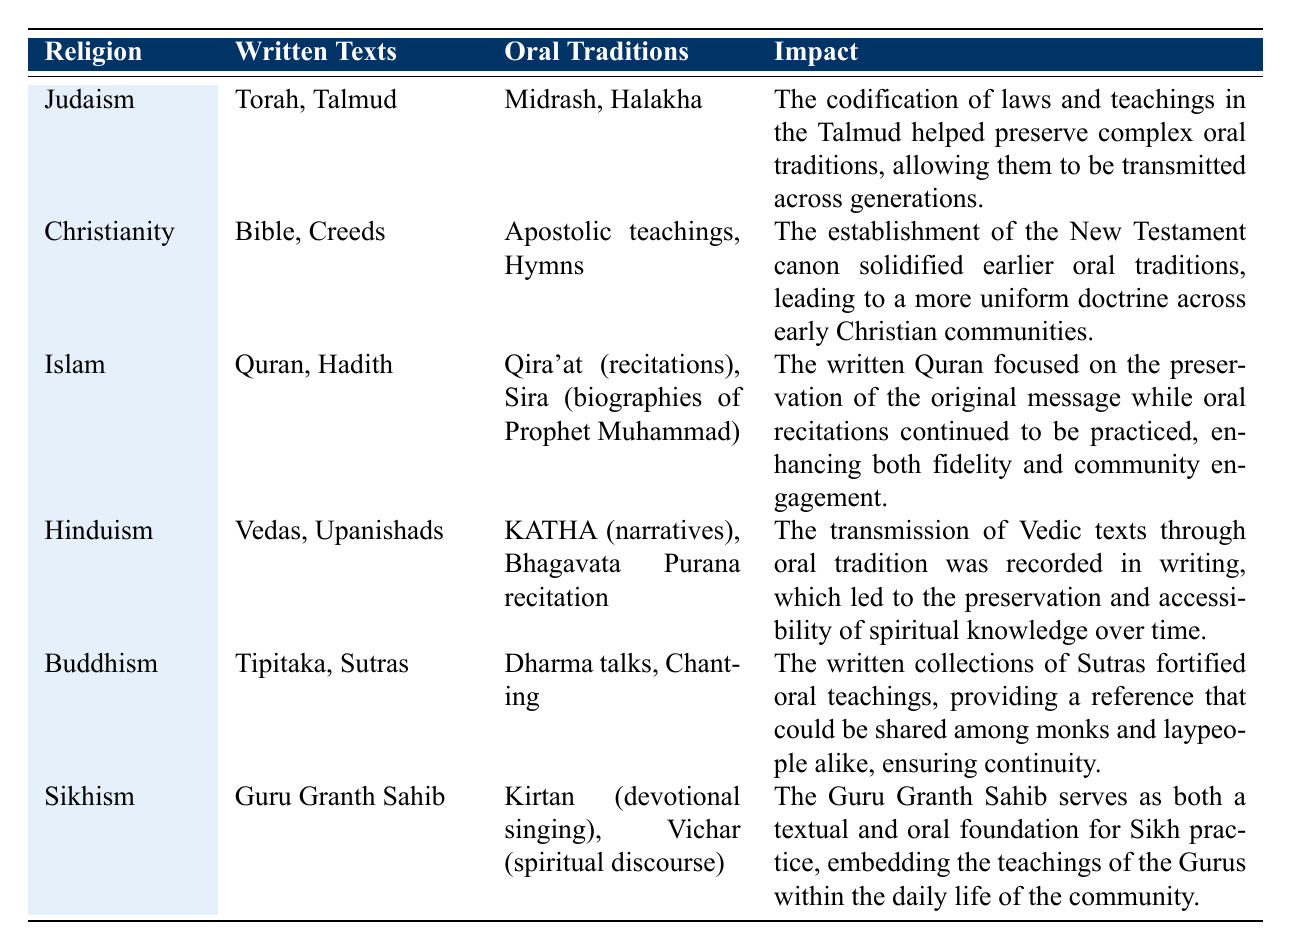What are the written texts associated with Buddhism? From the table, Buddhism is associated with the written texts "Tipitaka" and "Sutras."
Answer: Tipitaka, Sutras Which oral tradition is linked to Sikhism? The table indicates that Sikhism includes "Kirtan (devotional singing)" and "Vichar (spiritual discourse)" as its oral traditions.
Answer: Kirtan, Vichar Does the Talmud serve as a written text for Hinduism? According to the table, the Talmud is not mentioned in connection with Hinduism; rather, Hinduism is linked to the Vedas and Upanishads.
Answer: No What is the impact of the Quran on Islamic oral traditions? The impact section for Islam describes how the written Quran focused on preserving the original message while oral recitations continued to be practiced, enhancing fidelity and community engagement.
Answer: It preserved the message and enhanced community engagement Which religious community has the written text "Guru Granth Sahib"? The table clearly specifies that Sikhism has the written text "Guru Granth Sahib."
Answer: Sikhism How many oral traditions are mentioned for Judaism? The table lists two oral traditions for Judaism: "Midrash" and "Halakha," making a total of two.
Answer: Two What is the common theme in the impacts described for Christianity and Islam? Both Christianity and Islam emphasize the preservation and solidification of earlier oral traditions through their respective written texts, leading to a more structured practice and belief system.
Answer: Preservation of oral traditions Which religious community combines both a written and an oral foundation in its practice? The table mentions that Sikhism's "Guru Granth Sahib" serves as both a textual and oral foundation for its practices, embedding the teachings into daily life.
Answer: Sikhism If we compare the number of oral traditions in Hinduism and Buddhism, which has more? Hinduism lists two oral traditions ("KATHA" and "Bhagavata Purana recitation"), while Buddhism also lists two oral traditions ("Dharma talks" and "Chanting"), making them equal.
Answer: They have the same number In terms of impact, which religious community highlights the role of written texts in enhancing community engagement? The impact for Islam specifically mentions enhancing community engagement alongside preserving the original message of the Quran.
Answer: Islam 